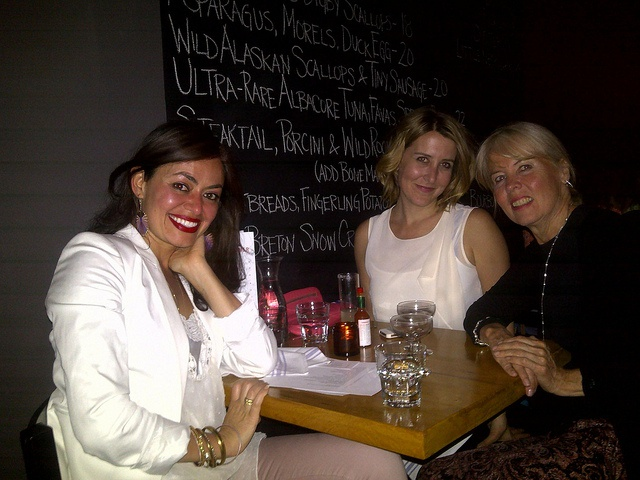Describe the objects in this image and their specific colors. I can see people in black, white, gray, and darkgray tones, people in black, maroon, and brown tones, dining table in black, maroon, and darkgray tones, people in black, darkgray, and brown tones, and cup in black, gray, maroon, and darkgray tones in this image. 